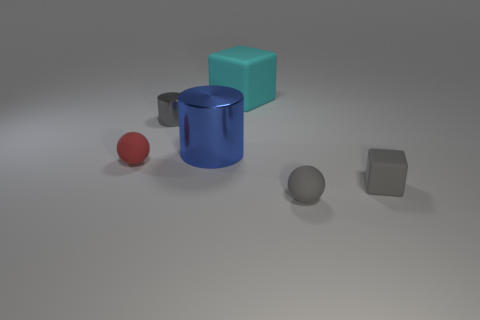Add 3 cyan things. How many objects exist? 9 Subtract 0 yellow cylinders. How many objects are left? 6 Subtract all green balls. Subtract all red cylinders. How many balls are left? 2 Subtract all large rubber things. Subtract all small gray matte balls. How many objects are left? 4 Add 6 large cyan things. How many large cyan things are left? 7 Add 3 large matte cylinders. How many large matte cylinders exist? 3 